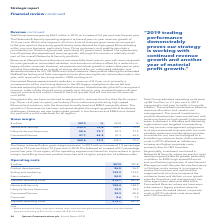According to Spirent Communications Plc's financial document, For adjusted operating costs, what was the amount of  Before exceptional items, acquisition related costs, acquired intangible asset amortisation and share-based payment in 2019? $4.3 million in total. The document states: "amortisation and share-based payment amounting to $4.3 million in total (2018 $19.6 million)...." Also, What is the change in the total group adjusted operating costs? According to the financial document, up $8.3 million. The relevant text states: "Total Group adjusted operating costs were up $8.3 million or 3.1 per cent in 2019 compared to last year, broadly in line with inflation. The emphasis remaine..." Also, What are the different business segments considered in the operating costs? The document contains multiple relevant values: Networks & Security, Lifecycle Service Assurance, Connected Devices, Corporate, Product Development, Selling and Marketing, Administration. From the document: "Networks & Security 158.4 148.9 Selling and marketing 129.2 123.9 Corporate 8.6 7.2 Lifecycle Service Assurance 70.5 70.5 Product development 96.5 96...." Additionally, In which year was the amount of operating costs under Networks & Security larger? According to the financial document, 2019. The relevant text states: "$ million 2019 % 2018 %..." Also, can you calculate: What was the change in costs under Corporate? Based on the calculation: 8.6-7.2, the result is 1.4 (in millions). This is based on the information: "Corporate 8.6 7.2 Corporate 8.6 7.2..." The key data points involved are: 7.2, 8.6. Also, can you calculate: What was the percentage change in costs under Corporate? To answer this question, I need to perform calculations using the financial data. The calculation is: (8.6-7.2)/7.2, which equals 19.44 (percentage). This is based on the information: "Corporate 8.6 7.2 Corporate 8.6 7.2..." The key data points involved are: 7.2, 8.6. 